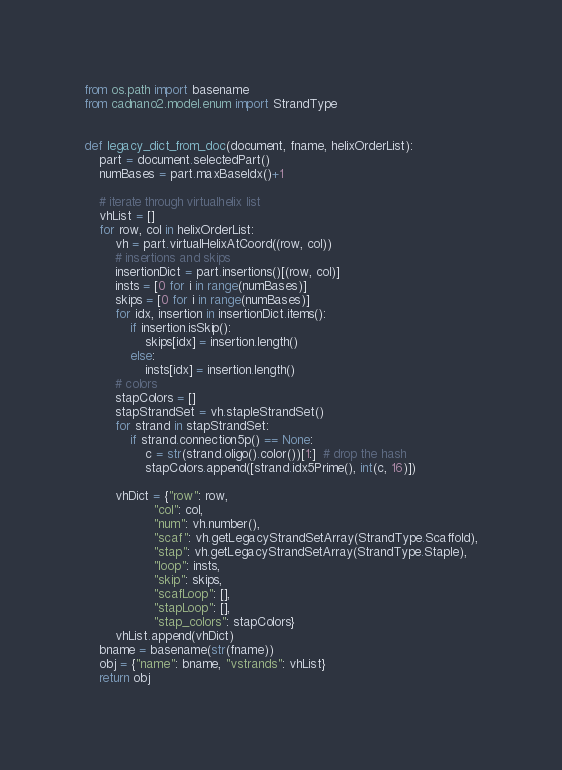Convert code to text. <code><loc_0><loc_0><loc_500><loc_500><_Python_>from os.path import basename
from cadnano2.model.enum import StrandType


def legacy_dict_from_doc(document, fname, helixOrderList):
    part = document.selectedPart()
    numBases = part.maxBaseIdx()+1

    # iterate through virtualhelix list
    vhList = []
    for row, col in helixOrderList:
        vh = part.virtualHelixAtCoord((row, col))
        # insertions and skips
        insertionDict = part.insertions()[(row, col)]
        insts = [0 for i in range(numBases)]
        skips = [0 for i in range(numBases)]
        for idx, insertion in insertionDict.items():
            if insertion.isSkip():
                skips[idx] = insertion.length()
            else:
                insts[idx] = insertion.length()
        # colors
        stapColors = []
        stapStrandSet = vh.stapleStrandSet()
        for strand in stapStrandSet:
            if strand.connection5p() == None:
                c = str(strand.oligo().color())[1:]  # drop the hash
                stapColors.append([strand.idx5Prime(), int(c, 16)])

        vhDict = {"row": row,
                  "col": col,
                  "num": vh.number(),
                  "scaf": vh.getLegacyStrandSetArray(StrandType.Scaffold),
                  "stap": vh.getLegacyStrandSetArray(StrandType.Staple),
                  "loop": insts,
                  "skip": skips,
                  "scafLoop": [],
                  "stapLoop": [],
                  "stap_colors": stapColors}
        vhList.append(vhDict)
    bname = basename(str(fname))
    obj = {"name": bname, "vstrands": vhList}
    return obj
</code> 